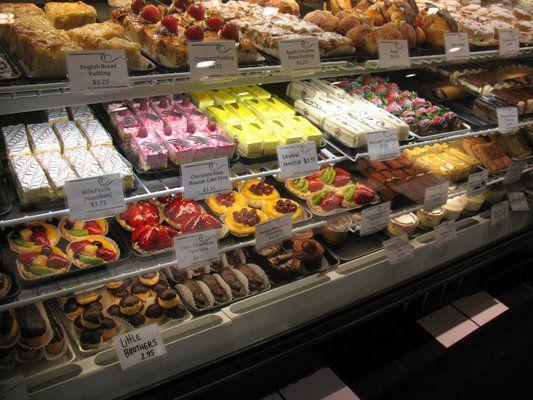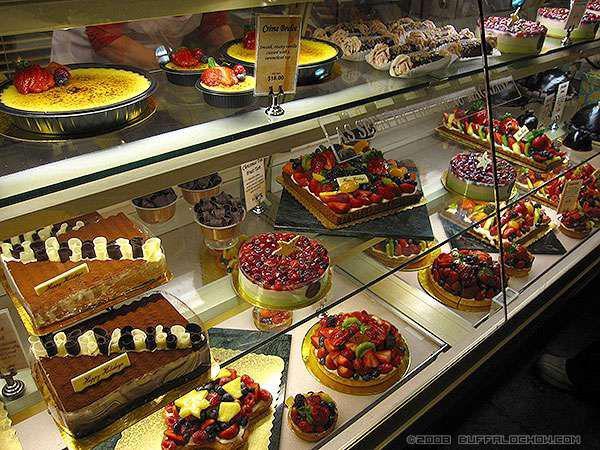The first image is the image on the left, the second image is the image on the right. Given the left and right images, does the statement "The display case on the right contains mostly round cake-like desserts that aren't covered in sliced fruits." hold true? Answer yes or no. No. The first image is the image on the left, the second image is the image on the right. Examine the images to the left and right. Is the description "some of the pastries have strawberries on top." accurate? Answer yes or no. Yes. 